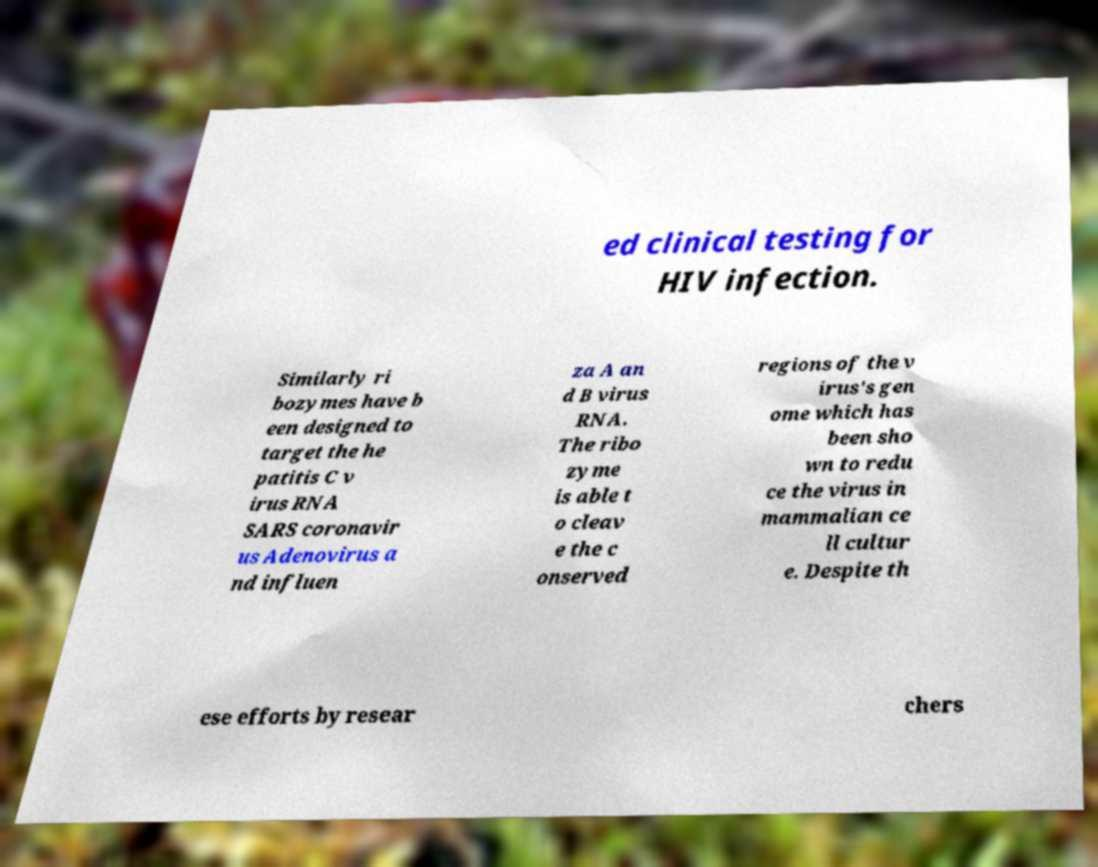Please identify and transcribe the text found in this image. ed clinical testing for HIV infection. Similarly ri bozymes have b een designed to target the he patitis C v irus RNA SARS coronavir us Adenovirus a nd influen za A an d B virus RNA. The ribo zyme is able t o cleav e the c onserved regions of the v irus's gen ome which has been sho wn to redu ce the virus in mammalian ce ll cultur e. Despite th ese efforts by resear chers 